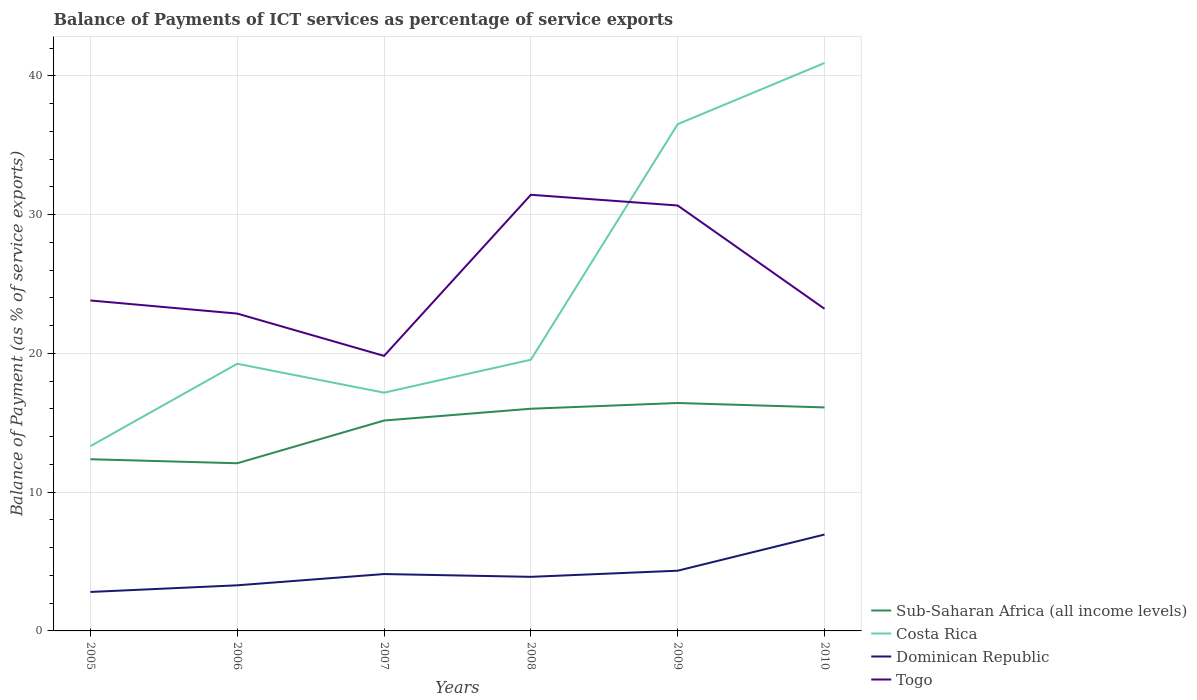How many different coloured lines are there?
Offer a very short reply. 4. Does the line corresponding to Sub-Saharan Africa (all income levels) intersect with the line corresponding to Costa Rica?
Make the answer very short. No. Across all years, what is the maximum balance of payments of ICT services in Togo?
Offer a terse response. 19.82. In which year was the balance of payments of ICT services in Dominican Republic maximum?
Provide a short and direct response. 2005. What is the total balance of payments of ICT services in Dominican Republic in the graph?
Give a very brief answer. -3.05. What is the difference between the highest and the second highest balance of payments of ICT services in Togo?
Your answer should be very brief. 11.61. Are the values on the major ticks of Y-axis written in scientific E-notation?
Your answer should be very brief. No. Does the graph contain grids?
Your response must be concise. Yes. How many legend labels are there?
Ensure brevity in your answer.  4. What is the title of the graph?
Provide a succinct answer. Balance of Payments of ICT services as percentage of service exports. Does "Kenya" appear as one of the legend labels in the graph?
Provide a short and direct response. No. What is the label or title of the Y-axis?
Your answer should be very brief. Balance of Payment (as % of service exports). What is the Balance of Payment (as % of service exports) of Sub-Saharan Africa (all income levels) in 2005?
Provide a succinct answer. 12.37. What is the Balance of Payment (as % of service exports) of Costa Rica in 2005?
Offer a very short reply. 13.32. What is the Balance of Payment (as % of service exports) of Dominican Republic in 2005?
Keep it short and to the point. 2.81. What is the Balance of Payment (as % of service exports) of Togo in 2005?
Offer a very short reply. 23.82. What is the Balance of Payment (as % of service exports) of Sub-Saharan Africa (all income levels) in 2006?
Your response must be concise. 12.08. What is the Balance of Payment (as % of service exports) of Costa Rica in 2006?
Keep it short and to the point. 19.25. What is the Balance of Payment (as % of service exports) of Dominican Republic in 2006?
Provide a succinct answer. 3.29. What is the Balance of Payment (as % of service exports) in Togo in 2006?
Give a very brief answer. 22.87. What is the Balance of Payment (as % of service exports) in Sub-Saharan Africa (all income levels) in 2007?
Make the answer very short. 15.16. What is the Balance of Payment (as % of service exports) in Costa Rica in 2007?
Ensure brevity in your answer.  17.17. What is the Balance of Payment (as % of service exports) in Dominican Republic in 2007?
Your answer should be very brief. 4.1. What is the Balance of Payment (as % of service exports) in Togo in 2007?
Your response must be concise. 19.82. What is the Balance of Payment (as % of service exports) of Sub-Saharan Africa (all income levels) in 2008?
Keep it short and to the point. 16.01. What is the Balance of Payment (as % of service exports) of Costa Rica in 2008?
Provide a short and direct response. 19.55. What is the Balance of Payment (as % of service exports) of Dominican Republic in 2008?
Your answer should be very brief. 3.9. What is the Balance of Payment (as % of service exports) in Togo in 2008?
Give a very brief answer. 31.43. What is the Balance of Payment (as % of service exports) of Sub-Saharan Africa (all income levels) in 2009?
Offer a very short reply. 16.43. What is the Balance of Payment (as % of service exports) of Costa Rica in 2009?
Provide a short and direct response. 36.52. What is the Balance of Payment (as % of service exports) of Dominican Republic in 2009?
Make the answer very short. 4.34. What is the Balance of Payment (as % of service exports) in Togo in 2009?
Provide a short and direct response. 30.66. What is the Balance of Payment (as % of service exports) of Sub-Saharan Africa (all income levels) in 2010?
Your response must be concise. 16.11. What is the Balance of Payment (as % of service exports) in Costa Rica in 2010?
Keep it short and to the point. 40.93. What is the Balance of Payment (as % of service exports) of Dominican Republic in 2010?
Make the answer very short. 6.95. What is the Balance of Payment (as % of service exports) of Togo in 2010?
Your answer should be very brief. 23.22. Across all years, what is the maximum Balance of Payment (as % of service exports) of Sub-Saharan Africa (all income levels)?
Your answer should be compact. 16.43. Across all years, what is the maximum Balance of Payment (as % of service exports) in Costa Rica?
Your answer should be very brief. 40.93. Across all years, what is the maximum Balance of Payment (as % of service exports) of Dominican Republic?
Offer a very short reply. 6.95. Across all years, what is the maximum Balance of Payment (as % of service exports) of Togo?
Provide a short and direct response. 31.43. Across all years, what is the minimum Balance of Payment (as % of service exports) in Sub-Saharan Africa (all income levels)?
Ensure brevity in your answer.  12.08. Across all years, what is the minimum Balance of Payment (as % of service exports) in Costa Rica?
Give a very brief answer. 13.32. Across all years, what is the minimum Balance of Payment (as % of service exports) of Dominican Republic?
Offer a terse response. 2.81. Across all years, what is the minimum Balance of Payment (as % of service exports) of Togo?
Your answer should be very brief. 19.82. What is the total Balance of Payment (as % of service exports) of Sub-Saharan Africa (all income levels) in the graph?
Keep it short and to the point. 88.17. What is the total Balance of Payment (as % of service exports) of Costa Rica in the graph?
Provide a succinct answer. 146.74. What is the total Balance of Payment (as % of service exports) in Dominican Republic in the graph?
Ensure brevity in your answer.  25.38. What is the total Balance of Payment (as % of service exports) of Togo in the graph?
Your response must be concise. 151.82. What is the difference between the Balance of Payment (as % of service exports) of Sub-Saharan Africa (all income levels) in 2005 and that in 2006?
Offer a terse response. 0.29. What is the difference between the Balance of Payment (as % of service exports) of Costa Rica in 2005 and that in 2006?
Your answer should be very brief. -5.94. What is the difference between the Balance of Payment (as % of service exports) in Dominican Republic in 2005 and that in 2006?
Ensure brevity in your answer.  -0.48. What is the difference between the Balance of Payment (as % of service exports) in Togo in 2005 and that in 2006?
Keep it short and to the point. 0.94. What is the difference between the Balance of Payment (as % of service exports) of Sub-Saharan Africa (all income levels) in 2005 and that in 2007?
Your answer should be compact. -2.79. What is the difference between the Balance of Payment (as % of service exports) in Costa Rica in 2005 and that in 2007?
Provide a short and direct response. -3.85. What is the difference between the Balance of Payment (as % of service exports) in Dominican Republic in 2005 and that in 2007?
Provide a short and direct response. -1.29. What is the difference between the Balance of Payment (as % of service exports) of Togo in 2005 and that in 2007?
Make the answer very short. 3.99. What is the difference between the Balance of Payment (as % of service exports) of Sub-Saharan Africa (all income levels) in 2005 and that in 2008?
Your answer should be very brief. -3.64. What is the difference between the Balance of Payment (as % of service exports) of Costa Rica in 2005 and that in 2008?
Your answer should be very brief. -6.23. What is the difference between the Balance of Payment (as % of service exports) of Dominican Republic in 2005 and that in 2008?
Your answer should be very brief. -1.09. What is the difference between the Balance of Payment (as % of service exports) of Togo in 2005 and that in 2008?
Your answer should be compact. -7.62. What is the difference between the Balance of Payment (as % of service exports) in Sub-Saharan Africa (all income levels) in 2005 and that in 2009?
Offer a terse response. -4.05. What is the difference between the Balance of Payment (as % of service exports) in Costa Rica in 2005 and that in 2009?
Your response must be concise. -23.21. What is the difference between the Balance of Payment (as % of service exports) of Dominican Republic in 2005 and that in 2009?
Offer a very short reply. -1.53. What is the difference between the Balance of Payment (as % of service exports) of Togo in 2005 and that in 2009?
Give a very brief answer. -6.84. What is the difference between the Balance of Payment (as % of service exports) of Sub-Saharan Africa (all income levels) in 2005 and that in 2010?
Your response must be concise. -3.73. What is the difference between the Balance of Payment (as % of service exports) in Costa Rica in 2005 and that in 2010?
Offer a very short reply. -27.61. What is the difference between the Balance of Payment (as % of service exports) in Dominican Republic in 2005 and that in 2010?
Your answer should be very brief. -4.14. What is the difference between the Balance of Payment (as % of service exports) in Togo in 2005 and that in 2010?
Offer a very short reply. 0.6. What is the difference between the Balance of Payment (as % of service exports) in Sub-Saharan Africa (all income levels) in 2006 and that in 2007?
Your answer should be compact. -3.08. What is the difference between the Balance of Payment (as % of service exports) of Costa Rica in 2006 and that in 2007?
Provide a short and direct response. 2.08. What is the difference between the Balance of Payment (as % of service exports) in Dominican Republic in 2006 and that in 2007?
Offer a terse response. -0.81. What is the difference between the Balance of Payment (as % of service exports) in Togo in 2006 and that in 2007?
Your answer should be very brief. 3.05. What is the difference between the Balance of Payment (as % of service exports) in Sub-Saharan Africa (all income levels) in 2006 and that in 2008?
Offer a very short reply. -3.93. What is the difference between the Balance of Payment (as % of service exports) of Costa Rica in 2006 and that in 2008?
Provide a short and direct response. -0.29. What is the difference between the Balance of Payment (as % of service exports) of Dominican Republic in 2006 and that in 2008?
Give a very brief answer. -0.61. What is the difference between the Balance of Payment (as % of service exports) of Togo in 2006 and that in 2008?
Your answer should be compact. -8.56. What is the difference between the Balance of Payment (as % of service exports) of Sub-Saharan Africa (all income levels) in 2006 and that in 2009?
Keep it short and to the point. -4.34. What is the difference between the Balance of Payment (as % of service exports) in Costa Rica in 2006 and that in 2009?
Make the answer very short. -17.27. What is the difference between the Balance of Payment (as % of service exports) of Dominican Republic in 2006 and that in 2009?
Ensure brevity in your answer.  -1.05. What is the difference between the Balance of Payment (as % of service exports) of Togo in 2006 and that in 2009?
Ensure brevity in your answer.  -7.79. What is the difference between the Balance of Payment (as % of service exports) of Sub-Saharan Africa (all income levels) in 2006 and that in 2010?
Give a very brief answer. -4.02. What is the difference between the Balance of Payment (as % of service exports) in Costa Rica in 2006 and that in 2010?
Keep it short and to the point. -21.68. What is the difference between the Balance of Payment (as % of service exports) in Dominican Republic in 2006 and that in 2010?
Your response must be concise. -3.66. What is the difference between the Balance of Payment (as % of service exports) of Togo in 2006 and that in 2010?
Give a very brief answer. -0.34. What is the difference between the Balance of Payment (as % of service exports) in Sub-Saharan Africa (all income levels) in 2007 and that in 2008?
Your response must be concise. -0.85. What is the difference between the Balance of Payment (as % of service exports) of Costa Rica in 2007 and that in 2008?
Keep it short and to the point. -2.38. What is the difference between the Balance of Payment (as % of service exports) of Dominican Republic in 2007 and that in 2008?
Provide a succinct answer. 0.2. What is the difference between the Balance of Payment (as % of service exports) of Togo in 2007 and that in 2008?
Make the answer very short. -11.61. What is the difference between the Balance of Payment (as % of service exports) in Sub-Saharan Africa (all income levels) in 2007 and that in 2009?
Offer a terse response. -1.26. What is the difference between the Balance of Payment (as % of service exports) in Costa Rica in 2007 and that in 2009?
Give a very brief answer. -19.35. What is the difference between the Balance of Payment (as % of service exports) in Dominican Republic in 2007 and that in 2009?
Make the answer very short. -0.24. What is the difference between the Balance of Payment (as % of service exports) of Togo in 2007 and that in 2009?
Provide a succinct answer. -10.84. What is the difference between the Balance of Payment (as % of service exports) in Sub-Saharan Africa (all income levels) in 2007 and that in 2010?
Your answer should be compact. -0.95. What is the difference between the Balance of Payment (as % of service exports) in Costa Rica in 2007 and that in 2010?
Your response must be concise. -23.76. What is the difference between the Balance of Payment (as % of service exports) of Dominican Republic in 2007 and that in 2010?
Ensure brevity in your answer.  -2.85. What is the difference between the Balance of Payment (as % of service exports) of Togo in 2007 and that in 2010?
Your answer should be compact. -3.39. What is the difference between the Balance of Payment (as % of service exports) of Sub-Saharan Africa (all income levels) in 2008 and that in 2009?
Keep it short and to the point. -0.41. What is the difference between the Balance of Payment (as % of service exports) of Costa Rica in 2008 and that in 2009?
Your answer should be compact. -16.98. What is the difference between the Balance of Payment (as % of service exports) in Dominican Republic in 2008 and that in 2009?
Make the answer very short. -0.44. What is the difference between the Balance of Payment (as % of service exports) of Togo in 2008 and that in 2009?
Your response must be concise. 0.77. What is the difference between the Balance of Payment (as % of service exports) in Sub-Saharan Africa (all income levels) in 2008 and that in 2010?
Make the answer very short. -0.09. What is the difference between the Balance of Payment (as % of service exports) of Costa Rica in 2008 and that in 2010?
Your answer should be compact. -21.38. What is the difference between the Balance of Payment (as % of service exports) of Dominican Republic in 2008 and that in 2010?
Keep it short and to the point. -3.05. What is the difference between the Balance of Payment (as % of service exports) in Togo in 2008 and that in 2010?
Offer a terse response. 8.22. What is the difference between the Balance of Payment (as % of service exports) of Sub-Saharan Africa (all income levels) in 2009 and that in 2010?
Give a very brief answer. 0.32. What is the difference between the Balance of Payment (as % of service exports) of Costa Rica in 2009 and that in 2010?
Your answer should be compact. -4.41. What is the difference between the Balance of Payment (as % of service exports) in Dominican Republic in 2009 and that in 2010?
Give a very brief answer. -2.61. What is the difference between the Balance of Payment (as % of service exports) in Togo in 2009 and that in 2010?
Make the answer very short. 7.44. What is the difference between the Balance of Payment (as % of service exports) in Sub-Saharan Africa (all income levels) in 2005 and the Balance of Payment (as % of service exports) in Costa Rica in 2006?
Offer a very short reply. -6.88. What is the difference between the Balance of Payment (as % of service exports) in Sub-Saharan Africa (all income levels) in 2005 and the Balance of Payment (as % of service exports) in Dominican Republic in 2006?
Give a very brief answer. 9.09. What is the difference between the Balance of Payment (as % of service exports) of Sub-Saharan Africa (all income levels) in 2005 and the Balance of Payment (as % of service exports) of Togo in 2006?
Offer a terse response. -10.5. What is the difference between the Balance of Payment (as % of service exports) in Costa Rica in 2005 and the Balance of Payment (as % of service exports) in Dominican Republic in 2006?
Your response must be concise. 10.03. What is the difference between the Balance of Payment (as % of service exports) in Costa Rica in 2005 and the Balance of Payment (as % of service exports) in Togo in 2006?
Provide a short and direct response. -9.55. What is the difference between the Balance of Payment (as % of service exports) in Dominican Republic in 2005 and the Balance of Payment (as % of service exports) in Togo in 2006?
Make the answer very short. -20.06. What is the difference between the Balance of Payment (as % of service exports) in Sub-Saharan Africa (all income levels) in 2005 and the Balance of Payment (as % of service exports) in Costa Rica in 2007?
Offer a very short reply. -4.8. What is the difference between the Balance of Payment (as % of service exports) in Sub-Saharan Africa (all income levels) in 2005 and the Balance of Payment (as % of service exports) in Dominican Republic in 2007?
Give a very brief answer. 8.28. What is the difference between the Balance of Payment (as % of service exports) in Sub-Saharan Africa (all income levels) in 2005 and the Balance of Payment (as % of service exports) in Togo in 2007?
Provide a succinct answer. -7.45. What is the difference between the Balance of Payment (as % of service exports) of Costa Rica in 2005 and the Balance of Payment (as % of service exports) of Dominican Republic in 2007?
Ensure brevity in your answer.  9.22. What is the difference between the Balance of Payment (as % of service exports) of Costa Rica in 2005 and the Balance of Payment (as % of service exports) of Togo in 2007?
Provide a short and direct response. -6.5. What is the difference between the Balance of Payment (as % of service exports) in Dominican Republic in 2005 and the Balance of Payment (as % of service exports) in Togo in 2007?
Offer a terse response. -17.01. What is the difference between the Balance of Payment (as % of service exports) of Sub-Saharan Africa (all income levels) in 2005 and the Balance of Payment (as % of service exports) of Costa Rica in 2008?
Your answer should be compact. -7.17. What is the difference between the Balance of Payment (as % of service exports) of Sub-Saharan Africa (all income levels) in 2005 and the Balance of Payment (as % of service exports) of Dominican Republic in 2008?
Your response must be concise. 8.48. What is the difference between the Balance of Payment (as % of service exports) in Sub-Saharan Africa (all income levels) in 2005 and the Balance of Payment (as % of service exports) in Togo in 2008?
Offer a very short reply. -19.06. What is the difference between the Balance of Payment (as % of service exports) in Costa Rica in 2005 and the Balance of Payment (as % of service exports) in Dominican Republic in 2008?
Your response must be concise. 9.42. What is the difference between the Balance of Payment (as % of service exports) in Costa Rica in 2005 and the Balance of Payment (as % of service exports) in Togo in 2008?
Give a very brief answer. -18.12. What is the difference between the Balance of Payment (as % of service exports) of Dominican Republic in 2005 and the Balance of Payment (as % of service exports) of Togo in 2008?
Provide a short and direct response. -28.63. What is the difference between the Balance of Payment (as % of service exports) of Sub-Saharan Africa (all income levels) in 2005 and the Balance of Payment (as % of service exports) of Costa Rica in 2009?
Keep it short and to the point. -24.15. What is the difference between the Balance of Payment (as % of service exports) of Sub-Saharan Africa (all income levels) in 2005 and the Balance of Payment (as % of service exports) of Dominican Republic in 2009?
Keep it short and to the point. 8.03. What is the difference between the Balance of Payment (as % of service exports) of Sub-Saharan Africa (all income levels) in 2005 and the Balance of Payment (as % of service exports) of Togo in 2009?
Ensure brevity in your answer.  -18.29. What is the difference between the Balance of Payment (as % of service exports) of Costa Rica in 2005 and the Balance of Payment (as % of service exports) of Dominican Republic in 2009?
Your answer should be very brief. 8.98. What is the difference between the Balance of Payment (as % of service exports) of Costa Rica in 2005 and the Balance of Payment (as % of service exports) of Togo in 2009?
Give a very brief answer. -17.34. What is the difference between the Balance of Payment (as % of service exports) in Dominican Republic in 2005 and the Balance of Payment (as % of service exports) in Togo in 2009?
Offer a terse response. -27.85. What is the difference between the Balance of Payment (as % of service exports) in Sub-Saharan Africa (all income levels) in 2005 and the Balance of Payment (as % of service exports) in Costa Rica in 2010?
Provide a succinct answer. -28.56. What is the difference between the Balance of Payment (as % of service exports) of Sub-Saharan Africa (all income levels) in 2005 and the Balance of Payment (as % of service exports) of Dominican Republic in 2010?
Ensure brevity in your answer.  5.43. What is the difference between the Balance of Payment (as % of service exports) in Sub-Saharan Africa (all income levels) in 2005 and the Balance of Payment (as % of service exports) in Togo in 2010?
Offer a very short reply. -10.84. What is the difference between the Balance of Payment (as % of service exports) of Costa Rica in 2005 and the Balance of Payment (as % of service exports) of Dominican Republic in 2010?
Your answer should be very brief. 6.37. What is the difference between the Balance of Payment (as % of service exports) in Costa Rica in 2005 and the Balance of Payment (as % of service exports) in Togo in 2010?
Keep it short and to the point. -9.9. What is the difference between the Balance of Payment (as % of service exports) of Dominican Republic in 2005 and the Balance of Payment (as % of service exports) of Togo in 2010?
Make the answer very short. -20.41. What is the difference between the Balance of Payment (as % of service exports) of Sub-Saharan Africa (all income levels) in 2006 and the Balance of Payment (as % of service exports) of Costa Rica in 2007?
Offer a terse response. -5.09. What is the difference between the Balance of Payment (as % of service exports) of Sub-Saharan Africa (all income levels) in 2006 and the Balance of Payment (as % of service exports) of Dominican Republic in 2007?
Keep it short and to the point. 7.99. What is the difference between the Balance of Payment (as % of service exports) in Sub-Saharan Africa (all income levels) in 2006 and the Balance of Payment (as % of service exports) in Togo in 2007?
Give a very brief answer. -7.74. What is the difference between the Balance of Payment (as % of service exports) of Costa Rica in 2006 and the Balance of Payment (as % of service exports) of Dominican Republic in 2007?
Your response must be concise. 15.16. What is the difference between the Balance of Payment (as % of service exports) of Costa Rica in 2006 and the Balance of Payment (as % of service exports) of Togo in 2007?
Offer a very short reply. -0.57. What is the difference between the Balance of Payment (as % of service exports) in Dominican Republic in 2006 and the Balance of Payment (as % of service exports) in Togo in 2007?
Your answer should be compact. -16.54. What is the difference between the Balance of Payment (as % of service exports) of Sub-Saharan Africa (all income levels) in 2006 and the Balance of Payment (as % of service exports) of Costa Rica in 2008?
Keep it short and to the point. -7.46. What is the difference between the Balance of Payment (as % of service exports) in Sub-Saharan Africa (all income levels) in 2006 and the Balance of Payment (as % of service exports) in Dominican Republic in 2008?
Make the answer very short. 8.19. What is the difference between the Balance of Payment (as % of service exports) in Sub-Saharan Africa (all income levels) in 2006 and the Balance of Payment (as % of service exports) in Togo in 2008?
Provide a succinct answer. -19.35. What is the difference between the Balance of Payment (as % of service exports) of Costa Rica in 2006 and the Balance of Payment (as % of service exports) of Dominican Republic in 2008?
Your answer should be compact. 15.36. What is the difference between the Balance of Payment (as % of service exports) in Costa Rica in 2006 and the Balance of Payment (as % of service exports) in Togo in 2008?
Your answer should be very brief. -12.18. What is the difference between the Balance of Payment (as % of service exports) of Dominican Republic in 2006 and the Balance of Payment (as % of service exports) of Togo in 2008?
Provide a succinct answer. -28.15. What is the difference between the Balance of Payment (as % of service exports) in Sub-Saharan Africa (all income levels) in 2006 and the Balance of Payment (as % of service exports) in Costa Rica in 2009?
Your answer should be compact. -24.44. What is the difference between the Balance of Payment (as % of service exports) of Sub-Saharan Africa (all income levels) in 2006 and the Balance of Payment (as % of service exports) of Dominican Republic in 2009?
Offer a very short reply. 7.74. What is the difference between the Balance of Payment (as % of service exports) of Sub-Saharan Africa (all income levels) in 2006 and the Balance of Payment (as % of service exports) of Togo in 2009?
Your answer should be very brief. -18.58. What is the difference between the Balance of Payment (as % of service exports) of Costa Rica in 2006 and the Balance of Payment (as % of service exports) of Dominican Republic in 2009?
Provide a short and direct response. 14.91. What is the difference between the Balance of Payment (as % of service exports) in Costa Rica in 2006 and the Balance of Payment (as % of service exports) in Togo in 2009?
Ensure brevity in your answer.  -11.41. What is the difference between the Balance of Payment (as % of service exports) of Dominican Republic in 2006 and the Balance of Payment (as % of service exports) of Togo in 2009?
Provide a short and direct response. -27.37. What is the difference between the Balance of Payment (as % of service exports) of Sub-Saharan Africa (all income levels) in 2006 and the Balance of Payment (as % of service exports) of Costa Rica in 2010?
Provide a short and direct response. -28.85. What is the difference between the Balance of Payment (as % of service exports) of Sub-Saharan Africa (all income levels) in 2006 and the Balance of Payment (as % of service exports) of Dominican Republic in 2010?
Your answer should be very brief. 5.14. What is the difference between the Balance of Payment (as % of service exports) of Sub-Saharan Africa (all income levels) in 2006 and the Balance of Payment (as % of service exports) of Togo in 2010?
Your response must be concise. -11.13. What is the difference between the Balance of Payment (as % of service exports) in Costa Rica in 2006 and the Balance of Payment (as % of service exports) in Dominican Republic in 2010?
Provide a succinct answer. 12.31. What is the difference between the Balance of Payment (as % of service exports) in Costa Rica in 2006 and the Balance of Payment (as % of service exports) in Togo in 2010?
Give a very brief answer. -3.96. What is the difference between the Balance of Payment (as % of service exports) of Dominican Republic in 2006 and the Balance of Payment (as % of service exports) of Togo in 2010?
Ensure brevity in your answer.  -19.93. What is the difference between the Balance of Payment (as % of service exports) in Sub-Saharan Africa (all income levels) in 2007 and the Balance of Payment (as % of service exports) in Costa Rica in 2008?
Your answer should be very brief. -4.38. What is the difference between the Balance of Payment (as % of service exports) in Sub-Saharan Africa (all income levels) in 2007 and the Balance of Payment (as % of service exports) in Dominican Republic in 2008?
Your answer should be compact. 11.27. What is the difference between the Balance of Payment (as % of service exports) of Sub-Saharan Africa (all income levels) in 2007 and the Balance of Payment (as % of service exports) of Togo in 2008?
Make the answer very short. -16.27. What is the difference between the Balance of Payment (as % of service exports) of Costa Rica in 2007 and the Balance of Payment (as % of service exports) of Dominican Republic in 2008?
Keep it short and to the point. 13.27. What is the difference between the Balance of Payment (as % of service exports) in Costa Rica in 2007 and the Balance of Payment (as % of service exports) in Togo in 2008?
Make the answer very short. -14.26. What is the difference between the Balance of Payment (as % of service exports) of Dominican Republic in 2007 and the Balance of Payment (as % of service exports) of Togo in 2008?
Provide a succinct answer. -27.33. What is the difference between the Balance of Payment (as % of service exports) in Sub-Saharan Africa (all income levels) in 2007 and the Balance of Payment (as % of service exports) in Costa Rica in 2009?
Give a very brief answer. -21.36. What is the difference between the Balance of Payment (as % of service exports) of Sub-Saharan Africa (all income levels) in 2007 and the Balance of Payment (as % of service exports) of Dominican Republic in 2009?
Provide a succinct answer. 10.82. What is the difference between the Balance of Payment (as % of service exports) in Sub-Saharan Africa (all income levels) in 2007 and the Balance of Payment (as % of service exports) in Togo in 2009?
Your answer should be very brief. -15.5. What is the difference between the Balance of Payment (as % of service exports) in Costa Rica in 2007 and the Balance of Payment (as % of service exports) in Dominican Republic in 2009?
Provide a short and direct response. 12.83. What is the difference between the Balance of Payment (as % of service exports) of Costa Rica in 2007 and the Balance of Payment (as % of service exports) of Togo in 2009?
Offer a very short reply. -13.49. What is the difference between the Balance of Payment (as % of service exports) of Dominican Republic in 2007 and the Balance of Payment (as % of service exports) of Togo in 2009?
Ensure brevity in your answer.  -26.56. What is the difference between the Balance of Payment (as % of service exports) in Sub-Saharan Africa (all income levels) in 2007 and the Balance of Payment (as % of service exports) in Costa Rica in 2010?
Your response must be concise. -25.77. What is the difference between the Balance of Payment (as % of service exports) in Sub-Saharan Africa (all income levels) in 2007 and the Balance of Payment (as % of service exports) in Dominican Republic in 2010?
Your answer should be compact. 8.22. What is the difference between the Balance of Payment (as % of service exports) in Sub-Saharan Africa (all income levels) in 2007 and the Balance of Payment (as % of service exports) in Togo in 2010?
Provide a short and direct response. -8.05. What is the difference between the Balance of Payment (as % of service exports) of Costa Rica in 2007 and the Balance of Payment (as % of service exports) of Dominican Republic in 2010?
Provide a short and direct response. 10.22. What is the difference between the Balance of Payment (as % of service exports) of Costa Rica in 2007 and the Balance of Payment (as % of service exports) of Togo in 2010?
Keep it short and to the point. -6.04. What is the difference between the Balance of Payment (as % of service exports) in Dominican Republic in 2007 and the Balance of Payment (as % of service exports) in Togo in 2010?
Your answer should be very brief. -19.12. What is the difference between the Balance of Payment (as % of service exports) in Sub-Saharan Africa (all income levels) in 2008 and the Balance of Payment (as % of service exports) in Costa Rica in 2009?
Your answer should be very brief. -20.51. What is the difference between the Balance of Payment (as % of service exports) of Sub-Saharan Africa (all income levels) in 2008 and the Balance of Payment (as % of service exports) of Dominican Republic in 2009?
Offer a terse response. 11.67. What is the difference between the Balance of Payment (as % of service exports) of Sub-Saharan Africa (all income levels) in 2008 and the Balance of Payment (as % of service exports) of Togo in 2009?
Provide a short and direct response. -14.65. What is the difference between the Balance of Payment (as % of service exports) in Costa Rica in 2008 and the Balance of Payment (as % of service exports) in Dominican Republic in 2009?
Provide a succinct answer. 15.21. What is the difference between the Balance of Payment (as % of service exports) of Costa Rica in 2008 and the Balance of Payment (as % of service exports) of Togo in 2009?
Offer a very short reply. -11.11. What is the difference between the Balance of Payment (as % of service exports) in Dominican Republic in 2008 and the Balance of Payment (as % of service exports) in Togo in 2009?
Your answer should be compact. -26.76. What is the difference between the Balance of Payment (as % of service exports) of Sub-Saharan Africa (all income levels) in 2008 and the Balance of Payment (as % of service exports) of Costa Rica in 2010?
Offer a terse response. -24.92. What is the difference between the Balance of Payment (as % of service exports) in Sub-Saharan Africa (all income levels) in 2008 and the Balance of Payment (as % of service exports) in Dominican Republic in 2010?
Offer a very short reply. 9.07. What is the difference between the Balance of Payment (as % of service exports) in Sub-Saharan Africa (all income levels) in 2008 and the Balance of Payment (as % of service exports) in Togo in 2010?
Provide a short and direct response. -7.2. What is the difference between the Balance of Payment (as % of service exports) in Costa Rica in 2008 and the Balance of Payment (as % of service exports) in Dominican Republic in 2010?
Provide a short and direct response. 12.6. What is the difference between the Balance of Payment (as % of service exports) in Costa Rica in 2008 and the Balance of Payment (as % of service exports) in Togo in 2010?
Provide a short and direct response. -3.67. What is the difference between the Balance of Payment (as % of service exports) in Dominican Republic in 2008 and the Balance of Payment (as % of service exports) in Togo in 2010?
Make the answer very short. -19.32. What is the difference between the Balance of Payment (as % of service exports) in Sub-Saharan Africa (all income levels) in 2009 and the Balance of Payment (as % of service exports) in Costa Rica in 2010?
Make the answer very short. -24.5. What is the difference between the Balance of Payment (as % of service exports) of Sub-Saharan Africa (all income levels) in 2009 and the Balance of Payment (as % of service exports) of Dominican Republic in 2010?
Give a very brief answer. 9.48. What is the difference between the Balance of Payment (as % of service exports) of Sub-Saharan Africa (all income levels) in 2009 and the Balance of Payment (as % of service exports) of Togo in 2010?
Offer a terse response. -6.79. What is the difference between the Balance of Payment (as % of service exports) in Costa Rica in 2009 and the Balance of Payment (as % of service exports) in Dominican Republic in 2010?
Your response must be concise. 29.58. What is the difference between the Balance of Payment (as % of service exports) in Costa Rica in 2009 and the Balance of Payment (as % of service exports) in Togo in 2010?
Offer a terse response. 13.31. What is the difference between the Balance of Payment (as % of service exports) in Dominican Republic in 2009 and the Balance of Payment (as % of service exports) in Togo in 2010?
Your answer should be compact. -18.88. What is the average Balance of Payment (as % of service exports) in Sub-Saharan Africa (all income levels) per year?
Make the answer very short. 14.7. What is the average Balance of Payment (as % of service exports) in Costa Rica per year?
Provide a succinct answer. 24.46. What is the average Balance of Payment (as % of service exports) of Dominican Republic per year?
Keep it short and to the point. 4.23. What is the average Balance of Payment (as % of service exports) of Togo per year?
Provide a short and direct response. 25.3. In the year 2005, what is the difference between the Balance of Payment (as % of service exports) of Sub-Saharan Africa (all income levels) and Balance of Payment (as % of service exports) of Costa Rica?
Provide a short and direct response. -0.94. In the year 2005, what is the difference between the Balance of Payment (as % of service exports) in Sub-Saharan Africa (all income levels) and Balance of Payment (as % of service exports) in Dominican Republic?
Give a very brief answer. 9.57. In the year 2005, what is the difference between the Balance of Payment (as % of service exports) in Sub-Saharan Africa (all income levels) and Balance of Payment (as % of service exports) in Togo?
Your answer should be compact. -11.44. In the year 2005, what is the difference between the Balance of Payment (as % of service exports) of Costa Rica and Balance of Payment (as % of service exports) of Dominican Republic?
Your response must be concise. 10.51. In the year 2005, what is the difference between the Balance of Payment (as % of service exports) of Costa Rica and Balance of Payment (as % of service exports) of Togo?
Your answer should be very brief. -10.5. In the year 2005, what is the difference between the Balance of Payment (as % of service exports) of Dominican Republic and Balance of Payment (as % of service exports) of Togo?
Provide a short and direct response. -21.01. In the year 2006, what is the difference between the Balance of Payment (as % of service exports) of Sub-Saharan Africa (all income levels) and Balance of Payment (as % of service exports) of Costa Rica?
Offer a very short reply. -7.17. In the year 2006, what is the difference between the Balance of Payment (as % of service exports) in Sub-Saharan Africa (all income levels) and Balance of Payment (as % of service exports) in Dominican Republic?
Your response must be concise. 8.8. In the year 2006, what is the difference between the Balance of Payment (as % of service exports) of Sub-Saharan Africa (all income levels) and Balance of Payment (as % of service exports) of Togo?
Make the answer very short. -10.79. In the year 2006, what is the difference between the Balance of Payment (as % of service exports) in Costa Rica and Balance of Payment (as % of service exports) in Dominican Republic?
Offer a terse response. 15.97. In the year 2006, what is the difference between the Balance of Payment (as % of service exports) in Costa Rica and Balance of Payment (as % of service exports) in Togo?
Provide a short and direct response. -3.62. In the year 2006, what is the difference between the Balance of Payment (as % of service exports) of Dominican Republic and Balance of Payment (as % of service exports) of Togo?
Offer a terse response. -19.58. In the year 2007, what is the difference between the Balance of Payment (as % of service exports) in Sub-Saharan Africa (all income levels) and Balance of Payment (as % of service exports) in Costa Rica?
Your answer should be very brief. -2.01. In the year 2007, what is the difference between the Balance of Payment (as % of service exports) of Sub-Saharan Africa (all income levels) and Balance of Payment (as % of service exports) of Dominican Republic?
Offer a very short reply. 11.06. In the year 2007, what is the difference between the Balance of Payment (as % of service exports) of Sub-Saharan Africa (all income levels) and Balance of Payment (as % of service exports) of Togo?
Keep it short and to the point. -4.66. In the year 2007, what is the difference between the Balance of Payment (as % of service exports) of Costa Rica and Balance of Payment (as % of service exports) of Dominican Republic?
Keep it short and to the point. 13.07. In the year 2007, what is the difference between the Balance of Payment (as % of service exports) of Costa Rica and Balance of Payment (as % of service exports) of Togo?
Ensure brevity in your answer.  -2.65. In the year 2007, what is the difference between the Balance of Payment (as % of service exports) in Dominican Republic and Balance of Payment (as % of service exports) in Togo?
Make the answer very short. -15.72. In the year 2008, what is the difference between the Balance of Payment (as % of service exports) of Sub-Saharan Africa (all income levels) and Balance of Payment (as % of service exports) of Costa Rica?
Provide a short and direct response. -3.53. In the year 2008, what is the difference between the Balance of Payment (as % of service exports) in Sub-Saharan Africa (all income levels) and Balance of Payment (as % of service exports) in Dominican Republic?
Your answer should be very brief. 12.12. In the year 2008, what is the difference between the Balance of Payment (as % of service exports) in Sub-Saharan Africa (all income levels) and Balance of Payment (as % of service exports) in Togo?
Offer a terse response. -15.42. In the year 2008, what is the difference between the Balance of Payment (as % of service exports) in Costa Rica and Balance of Payment (as % of service exports) in Dominican Republic?
Keep it short and to the point. 15.65. In the year 2008, what is the difference between the Balance of Payment (as % of service exports) of Costa Rica and Balance of Payment (as % of service exports) of Togo?
Make the answer very short. -11.89. In the year 2008, what is the difference between the Balance of Payment (as % of service exports) in Dominican Republic and Balance of Payment (as % of service exports) in Togo?
Offer a very short reply. -27.54. In the year 2009, what is the difference between the Balance of Payment (as % of service exports) of Sub-Saharan Africa (all income levels) and Balance of Payment (as % of service exports) of Costa Rica?
Your answer should be very brief. -20.1. In the year 2009, what is the difference between the Balance of Payment (as % of service exports) in Sub-Saharan Africa (all income levels) and Balance of Payment (as % of service exports) in Dominican Republic?
Provide a succinct answer. 12.09. In the year 2009, what is the difference between the Balance of Payment (as % of service exports) of Sub-Saharan Africa (all income levels) and Balance of Payment (as % of service exports) of Togo?
Offer a very short reply. -14.23. In the year 2009, what is the difference between the Balance of Payment (as % of service exports) of Costa Rica and Balance of Payment (as % of service exports) of Dominican Republic?
Provide a short and direct response. 32.18. In the year 2009, what is the difference between the Balance of Payment (as % of service exports) in Costa Rica and Balance of Payment (as % of service exports) in Togo?
Make the answer very short. 5.86. In the year 2009, what is the difference between the Balance of Payment (as % of service exports) of Dominican Republic and Balance of Payment (as % of service exports) of Togo?
Ensure brevity in your answer.  -26.32. In the year 2010, what is the difference between the Balance of Payment (as % of service exports) in Sub-Saharan Africa (all income levels) and Balance of Payment (as % of service exports) in Costa Rica?
Offer a terse response. -24.82. In the year 2010, what is the difference between the Balance of Payment (as % of service exports) of Sub-Saharan Africa (all income levels) and Balance of Payment (as % of service exports) of Dominican Republic?
Provide a succinct answer. 9.16. In the year 2010, what is the difference between the Balance of Payment (as % of service exports) of Sub-Saharan Africa (all income levels) and Balance of Payment (as % of service exports) of Togo?
Offer a very short reply. -7.11. In the year 2010, what is the difference between the Balance of Payment (as % of service exports) in Costa Rica and Balance of Payment (as % of service exports) in Dominican Republic?
Your answer should be very brief. 33.98. In the year 2010, what is the difference between the Balance of Payment (as % of service exports) of Costa Rica and Balance of Payment (as % of service exports) of Togo?
Your answer should be compact. 17.71. In the year 2010, what is the difference between the Balance of Payment (as % of service exports) in Dominican Republic and Balance of Payment (as % of service exports) in Togo?
Offer a terse response. -16.27. What is the ratio of the Balance of Payment (as % of service exports) of Sub-Saharan Africa (all income levels) in 2005 to that in 2006?
Make the answer very short. 1.02. What is the ratio of the Balance of Payment (as % of service exports) in Costa Rica in 2005 to that in 2006?
Offer a very short reply. 0.69. What is the ratio of the Balance of Payment (as % of service exports) of Dominican Republic in 2005 to that in 2006?
Provide a succinct answer. 0.85. What is the ratio of the Balance of Payment (as % of service exports) in Togo in 2005 to that in 2006?
Ensure brevity in your answer.  1.04. What is the ratio of the Balance of Payment (as % of service exports) in Sub-Saharan Africa (all income levels) in 2005 to that in 2007?
Give a very brief answer. 0.82. What is the ratio of the Balance of Payment (as % of service exports) of Costa Rica in 2005 to that in 2007?
Your answer should be compact. 0.78. What is the ratio of the Balance of Payment (as % of service exports) in Dominican Republic in 2005 to that in 2007?
Your answer should be very brief. 0.69. What is the ratio of the Balance of Payment (as % of service exports) in Togo in 2005 to that in 2007?
Your response must be concise. 1.2. What is the ratio of the Balance of Payment (as % of service exports) of Sub-Saharan Africa (all income levels) in 2005 to that in 2008?
Ensure brevity in your answer.  0.77. What is the ratio of the Balance of Payment (as % of service exports) of Costa Rica in 2005 to that in 2008?
Make the answer very short. 0.68. What is the ratio of the Balance of Payment (as % of service exports) of Dominican Republic in 2005 to that in 2008?
Offer a very short reply. 0.72. What is the ratio of the Balance of Payment (as % of service exports) of Togo in 2005 to that in 2008?
Your answer should be very brief. 0.76. What is the ratio of the Balance of Payment (as % of service exports) in Sub-Saharan Africa (all income levels) in 2005 to that in 2009?
Provide a short and direct response. 0.75. What is the ratio of the Balance of Payment (as % of service exports) in Costa Rica in 2005 to that in 2009?
Keep it short and to the point. 0.36. What is the ratio of the Balance of Payment (as % of service exports) of Dominican Republic in 2005 to that in 2009?
Provide a short and direct response. 0.65. What is the ratio of the Balance of Payment (as % of service exports) of Togo in 2005 to that in 2009?
Provide a succinct answer. 0.78. What is the ratio of the Balance of Payment (as % of service exports) in Sub-Saharan Africa (all income levels) in 2005 to that in 2010?
Provide a succinct answer. 0.77. What is the ratio of the Balance of Payment (as % of service exports) of Costa Rica in 2005 to that in 2010?
Make the answer very short. 0.33. What is the ratio of the Balance of Payment (as % of service exports) in Dominican Republic in 2005 to that in 2010?
Your answer should be compact. 0.4. What is the ratio of the Balance of Payment (as % of service exports) in Togo in 2005 to that in 2010?
Your answer should be very brief. 1.03. What is the ratio of the Balance of Payment (as % of service exports) in Sub-Saharan Africa (all income levels) in 2006 to that in 2007?
Your answer should be very brief. 0.8. What is the ratio of the Balance of Payment (as % of service exports) of Costa Rica in 2006 to that in 2007?
Ensure brevity in your answer.  1.12. What is the ratio of the Balance of Payment (as % of service exports) of Dominican Republic in 2006 to that in 2007?
Your answer should be very brief. 0.8. What is the ratio of the Balance of Payment (as % of service exports) of Togo in 2006 to that in 2007?
Give a very brief answer. 1.15. What is the ratio of the Balance of Payment (as % of service exports) of Sub-Saharan Africa (all income levels) in 2006 to that in 2008?
Provide a short and direct response. 0.75. What is the ratio of the Balance of Payment (as % of service exports) in Costa Rica in 2006 to that in 2008?
Give a very brief answer. 0.99. What is the ratio of the Balance of Payment (as % of service exports) in Dominican Republic in 2006 to that in 2008?
Make the answer very short. 0.84. What is the ratio of the Balance of Payment (as % of service exports) in Togo in 2006 to that in 2008?
Provide a short and direct response. 0.73. What is the ratio of the Balance of Payment (as % of service exports) in Sub-Saharan Africa (all income levels) in 2006 to that in 2009?
Your answer should be very brief. 0.74. What is the ratio of the Balance of Payment (as % of service exports) in Costa Rica in 2006 to that in 2009?
Give a very brief answer. 0.53. What is the ratio of the Balance of Payment (as % of service exports) of Dominican Republic in 2006 to that in 2009?
Provide a succinct answer. 0.76. What is the ratio of the Balance of Payment (as % of service exports) of Togo in 2006 to that in 2009?
Your answer should be compact. 0.75. What is the ratio of the Balance of Payment (as % of service exports) in Sub-Saharan Africa (all income levels) in 2006 to that in 2010?
Provide a short and direct response. 0.75. What is the ratio of the Balance of Payment (as % of service exports) in Costa Rica in 2006 to that in 2010?
Make the answer very short. 0.47. What is the ratio of the Balance of Payment (as % of service exports) in Dominican Republic in 2006 to that in 2010?
Offer a terse response. 0.47. What is the ratio of the Balance of Payment (as % of service exports) of Togo in 2006 to that in 2010?
Your response must be concise. 0.99. What is the ratio of the Balance of Payment (as % of service exports) of Sub-Saharan Africa (all income levels) in 2007 to that in 2008?
Provide a succinct answer. 0.95. What is the ratio of the Balance of Payment (as % of service exports) of Costa Rica in 2007 to that in 2008?
Your response must be concise. 0.88. What is the ratio of the Balance of Payment (as % of service exports) in Dominican Republic in 2007 to that in 2008?
Offer a very short reply. 1.05. What is the ratio of the Balance of Payment (as % of service exports) in Togo in 2007 to that in 2008?
Ensure brevity in your answer.  0.63. What is the ratio of the Balance of Payment (as % of service exports) in Costa Rica in 2007 to that in 2009?
Keep it short and to the point. 0.47. What is the ratio of the Balance of Payment (as % of service exports) in Dominican Republic in 2007 to that in 2009?
Provide a short and direct response. 0.94. What is the ratio of the Balance of Payment (as % of service exports) in Togo in 2007 to that in 2009?
Provide a succinct answer. 0.65. What is the ratio of the Balance of Payment (as % of service exports) in Sub-Saharan Africa (all income levels) in 2007 to that in 2010?
Your answer should be compact. 0.94. What is the ratio of the Balance of Payment (as % of service exports) of Costa Rica in 2007 to that in 2010?
Offer a very short reply. 0.42. What is the ratio of the Balance of Payment (as % of service exports) in Dominican Republic in 2007 to that in 2010?
Offer a terse response. 0.59. What is the ratio of the Balance of Payment (as % of service exports) in Togo in 2007 to that in 2010?
Provide a short and direct response. 0.85. What is the ratio of the Balance of Payment (as % of service exports) of Sub-Saharan Africa (all income levels) in 2008 to that in 2009?
Ensure brevity in your answer.  0.97. What is the ratio of the Balance of Payment (as % of service exports) of Costa Rica in 2008 to that in 2009?
Offer a terse response. 0.54. What is the ratio of the Balance of Payment (as % of service exports) of Dominican Republic in 2008 to that in 2009?
Make the answer very short. 0.9. What is the ratio of the Balance of Payment (as % of service exports) in Togo in 2008 to that in 2009?
Provide a short and direct response. 1.03. What is the ratio of the Balance of Payment (as % of service exports) in Sub-Saharan Africa (all income levels) in 2008 to that in 2010?
Your answer should be compact. 0.99. What is the ratio of the Balance of Payment (as % of service exports) in Costa Rica in 2008 to that in 2010?
Ensure brevity in your answer.  0.48. What is the ratio of the Balance of Payment (as % of service exports) in Dominican Republic in 2008 to that in 2010?
Offer a very short reply. 0.56. What is the ratio of the Balance of Payment (as % of service exports) of Togo in 2008 to that in 2010?
Your answer should be compact. 1.35. What is the ratio of the Balance of Payment (as % of service exports) of Sub-Saharan Africa (all income levels) in 2009 to that in 2010?
Ensure brevity in your answer.  1.02. What is the ratio of the Balance of Payment (as % of service exports) in Costa Rica in 2009 to that in 2010?
Your response must be concise. 0.89. What is the ratio of the Balance of Payment (as % of service exports) of Dominican Republic in 2009 to that in 2010?
Offer a very short reply. 0.62. What is the ratio of the Balance of Payment (as % of service exports) of Togo in 2009 to that in 2010?
Keep it short and to the point. 1.32. What is the difference between the highest and the second highest Balance of Payment (as % of service exports) in Sub-Saharan Africa (all income levels)?
Keep it short and to the point. 0.32. What is the difference between the highest and the second highest Balance of Payment (as % of service exports) in Costa Rica?
Offer a terse response. 4.41. What is the difference between the highest and the second highest Balance of Payment (as % of service exports) of Dominican Republic?
Give a very brief answer. 2.61. What is the difference between the highest and the second highest Balance of Payment (as % of service exports) in Togo?
Provide a succinct answer. 0.77. What is the difference between the highest and the lowest Balance of Payment (as % of service exports) in Sub-Saharan Africa (all income levels)?
Your answer should be very brief. 4.34. What is the difference between the highest and the lowest Balance of Payment (as % of service exports) of Costa Rica?
Keep it short and to the point. 27.61. What is the difference between the highest and the lowest Balance of Payment (as % of service exports) in Dominican Republic?
Your response must be concise. 4.14. What is the difference between the highest and the lowest Balance of Payment (as % of service exports) of Togo?
Keep it short and to the point. 11.61. 